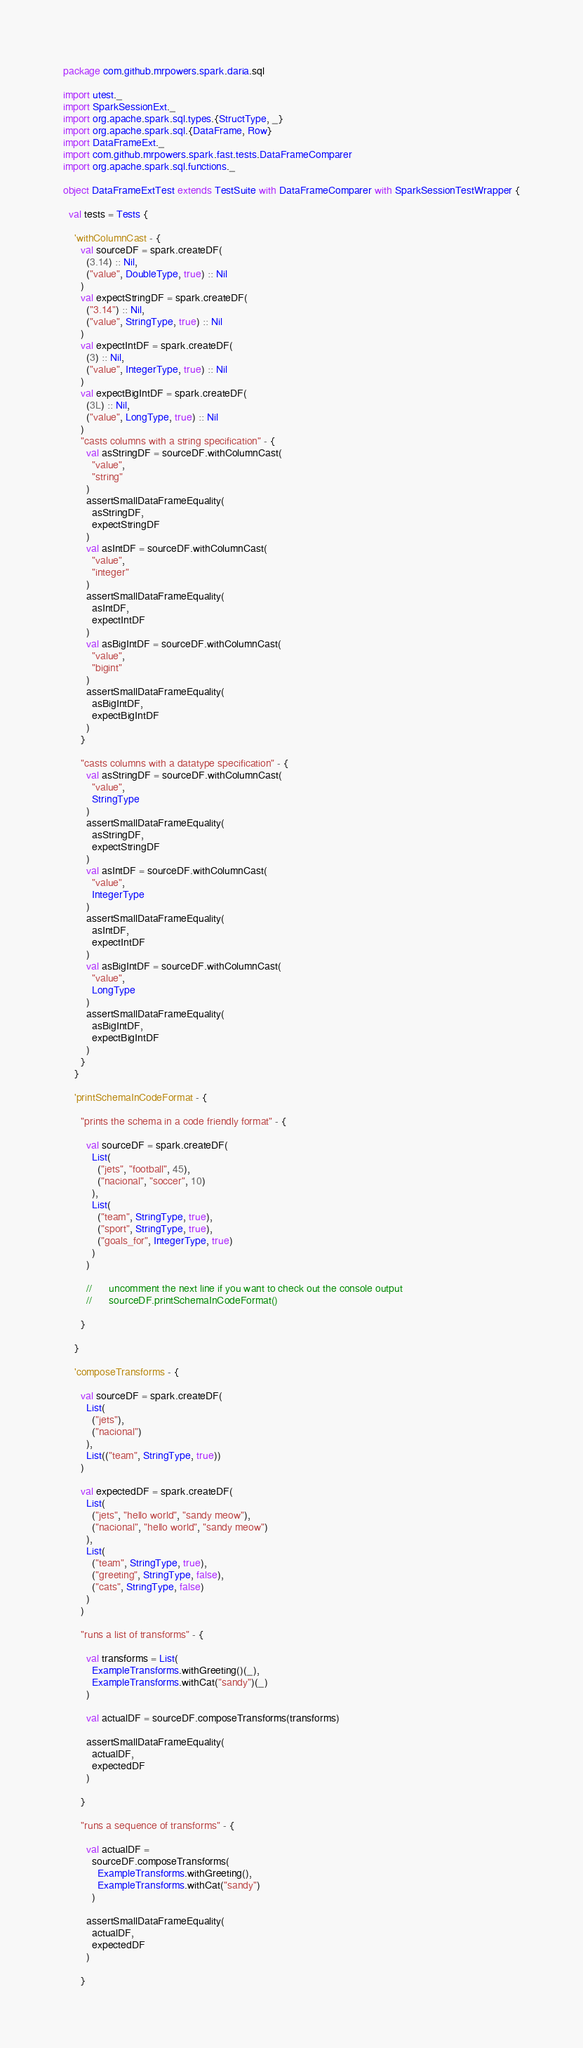Convert code to text. <code><loc_0><loc_0><loc_500><loc_500><_Scala_>package com.github.mrpowers.spark.daria.sql

import utest._
import SparkSessionExt._
import org.apache.spark.sql.types.{StructType, _}
import org.apache.spark.sql.{DataFrame, Row}
import DataFrameExt._
import com.github.mrpowers.spark.fast.tests.DataFrameComparer
import org.apache.spark.sql.functions._

object DataFrameExtTest extends TestSuite with DataFrameComparer with SparkSessionTestWrapper {

  val tests = Tests {

    'withColumnCast - {
      val sourceDF = spark.createDF(
        (3.14) :: Nil,
        ("value", DoubleType, true) :: Nil
      )
      val expectStringDF = spark.createDF(
        ("3.14") :: Nil,
        ("value", StringType, true) :: Nil
      )
      val expectIntDF = spark.createDF(
        (3) :: Nil,
        ("value", IntegerType, true) :: Nil
      )
      val expectBigIntDF = spark.createDF(
        (3L) :: Nil,
        ("value", LongType, true) :: Nil
      )
      "casts columns with a string specification" - {
        val asStringDF = sourceDF.withColumnCast(
          "value",
          "string"
        )
        assertSmallDataFrameEquality(
          asStringDF,
          expectStringDF
        )
        val asIntDF = sourceDF.withColumnCast(
          "value",
          "integer"
        )
        assertSmallDataFrameEquality(
          asIntDF,
          expectIntDF
        )
        val asBigIntDF = sourceDF.withColumnCast(
          "value",
          "bigint"
        )
        assertSmallDataFrameEquality(
          asBigIntDF,
          expectBigIntDF
        )
      }

      "casts columns with a datatype specification" - {
        val asStringDF = sourceDF.withColumnCast(
          "value",
          StringType
        )
        assertSmallDataFrameEquality(
          asStringDF,
          expectStringDF
        )
        val asIntDF = sourceDF.withColumnCast(
          "value",
          IntegerType
        )
        assertSmallDataFrameEquality(
          asIntDF,
          expectIntDF
        )
        val asBigIntDF = sourceDF.withColumnCast(
          "value",
          LongType
        )
        assertSmallDataFrameEquality(
          asBigIntDF,
          expectBigIntDF
        )
      }
    }

    'printSchemaInCodeFormat - {

      "prints the schema in a code friendly format" - {

        val sourceDF = spark.createDF(
          List(
            ("jets", "football", 45),
            ("nacional", "soccer", 10)
          ),
          List(
            ("team", StringType, true),
            ("sport", StringType, true),
            ("goals_for", IntegerType, true)
          )
        )

        //      uncomment the next line if you want to check out the console output
        //      sourceDF.printSchemaInCodeFormat()

      }

    }

    'composeTransforms - {

      val sourceDF = spark.createDF(
        List(
          ("jets"),
          ("nacional")
        ),
        List(("team", StringType, true))
      )

      val expectedDF = spark.createDF(
        List(
          ("jets", "hello world", "sandy meow"),
          ("nacional", "hello world", "sandy meow")
        ),
        List(
          ("team", StringType, true),
          ("greeting", StringType, false),
          ("cats", StringType, false)
        )
      )

      "runs a list of transforms" - {

        val transforms = List(
          ExampleTransforms.withGreeting()(_),
          ExampleTransforms.withCat("sandy")(_)
        )

        val actualDF = sourceDF.composeTransforms(transforms)

        assertSmallDataFrameEquality(
          actualDF,
          expectedDF
        )

      }

      "runs a sequence of transforms" - {

        val actualDF =
          sourceDF.composeTransforms(
            ExampleTransforms.withGreeting(),
            ExampleTransforms.withCat("sandy")
          )

        assertSmallDataFrameEquality(
          actualDF,
          expectedDF
        )

      }
</code> 